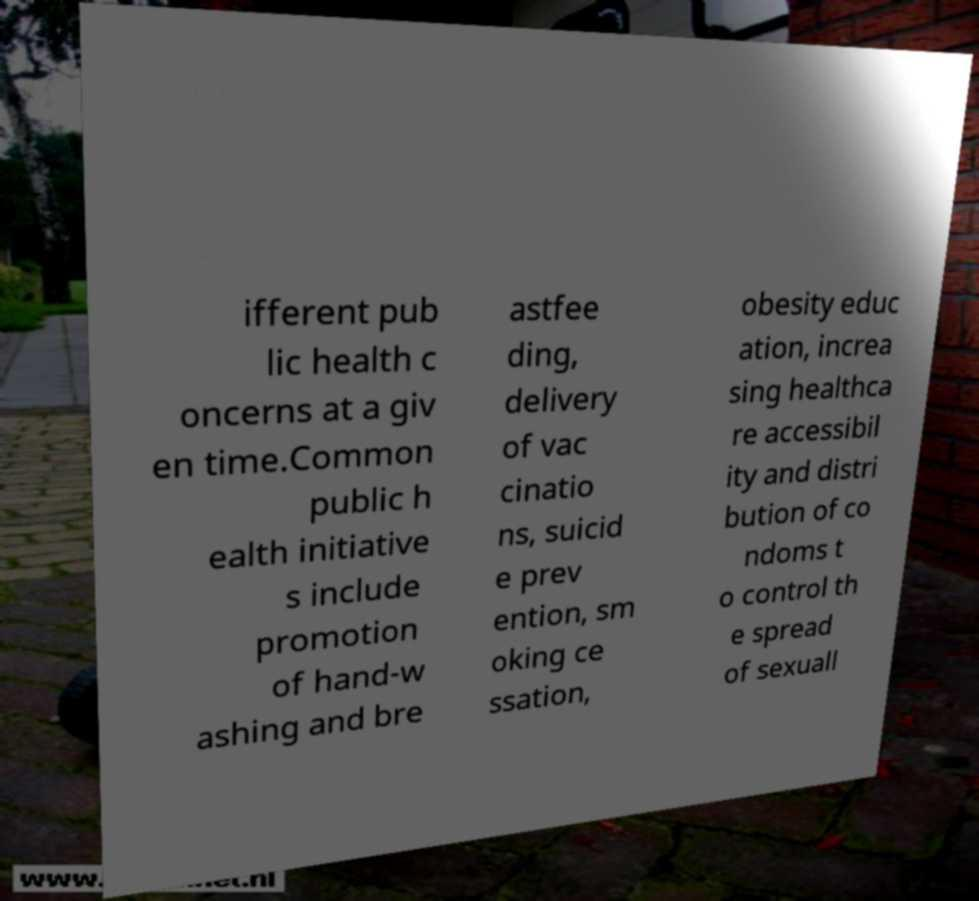Could you assist in decoding the text presented in this image and type it out clearly? ifferent pub lic health c oncerns at a giv en time.Common public h ealth initiative s include promotion of hand-w ashing and bre astfee ding, delivery of vac cinatio ns, suicid e prev ention, sm oking ce ssation, obesity educ ation, increa sing healthca re accessibil ity and distri bution of co ndoms t o control th e spread of sexuall 